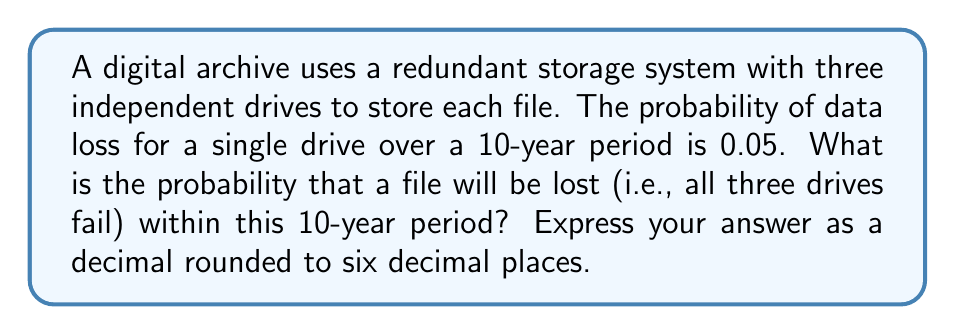Teach me how to tackle this problem. To solve this problem, we'll follow these steps:

1) First, we need to understand what constitutes a file loss. A file is lost only if all three drives fail. 

2) We're given the probability of a single drive failing: $p = 0.05$

3) The probability of a single drive not failing is therefore: $1 - p = 0.95$

4) For the file to be preserved, at least one drive must not fail. We can calculate this as the complement of all drives failing.

5) The probability of all three drives failing is:

   $P(\text{all fail}) = 0.05 * 0.05 * 0.05 = 0.05^3$

6) Therefore, the probability of at least one drive surviving (and thus the file being preserved) is:

   $P(\text{file preserved}) = 1 - 0.05^3$

7) The probability of the file being lost is the complement of this:

   $P(\text{file lost}) = 1 - (1 - 0.05^3)$
                        $= 0.05^3$

8) Let's calculate this:

   $0.05^3 = 0.000125$

9) Rounding to six decimal places:

   $0.000125 = 0.000125$

Thus, the probability of file loss in this system over a 10-year period is 0.000125.
Answer: 0.000125 